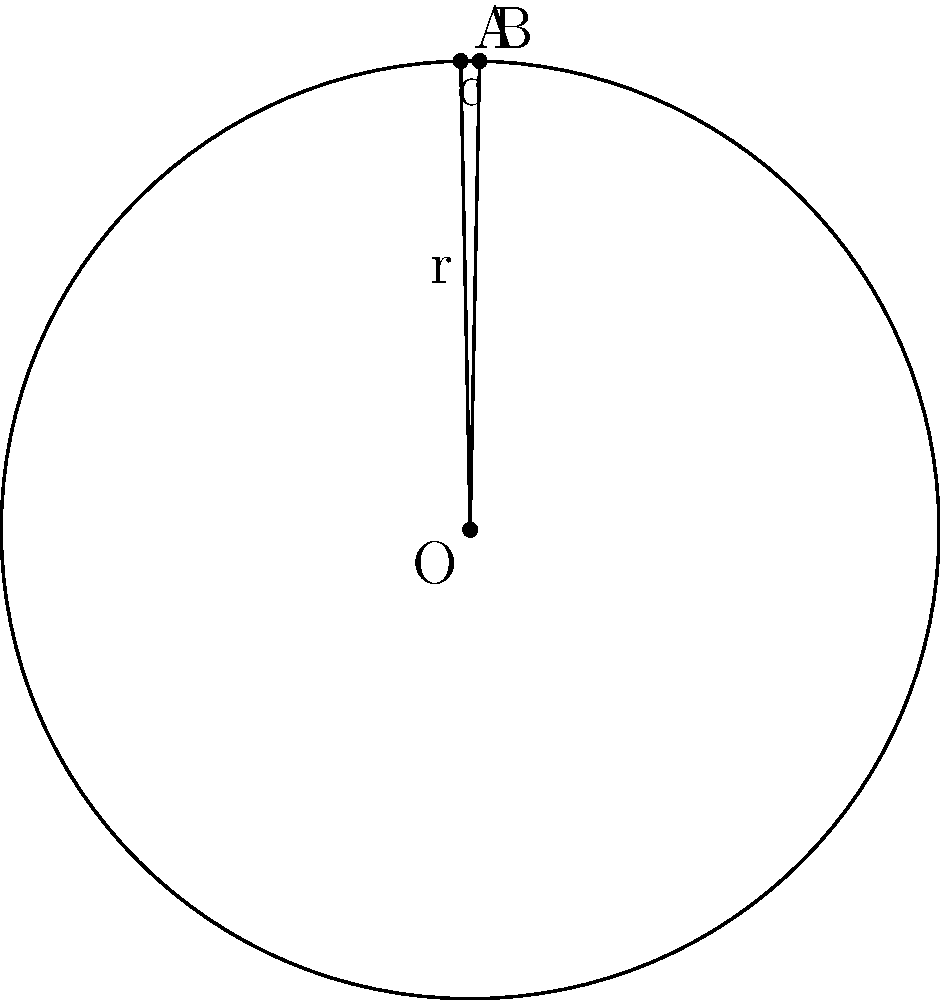In a circular segment, the chord length (c) is 4 units and the radius (r) of the circle is 3 units. Calculate the area of the circular segment, rounding your answer to two decimal places. Assume $\pi = 3.14$ for this calculation. To calculate the area of a circular segment, we'll follow these steps:

1) First, we need to find the central angle $\theta$ (in radians):
   
   Using the formula: $\cos(\theta/2) = \frac{r - h}{r}$, where $h$ is the height of the segment.
   
   We can find $h$ using the Pythagorean theorem: $h = r - \sqrt{r^2 - (c/2)^2}$
   
   $h = 3 - \sqrt{3^2 - (4/2)^2} = 3 - \sqrt{9 - 4} = 3 - \sqrt{5} \approx 0.764$

   Now, $\cos(\theta/2) = \frac{3 - 0.764}{3} = 0.745$
   
   $\theta = 2 \cdot \arccos(0.745) \approx 1.536$ radians

2) The area of a circular segment is given by the formula:
   
   $A = r^2 \cdot (\theta - \sin\theta)$

3) Substituting our values:
   
   $A = 3^2 \cdot (1.536 - \sin(1.536))$
   $A = 9 \cdot (1.536 - 0.999)$
   $A = 9 \cdot 0.537$
   $A \approx 4.833$ square units

4) Rounding to two decimal places:
   
   $A \approx 4.83$ square units
Answer: $4.83$ square units 